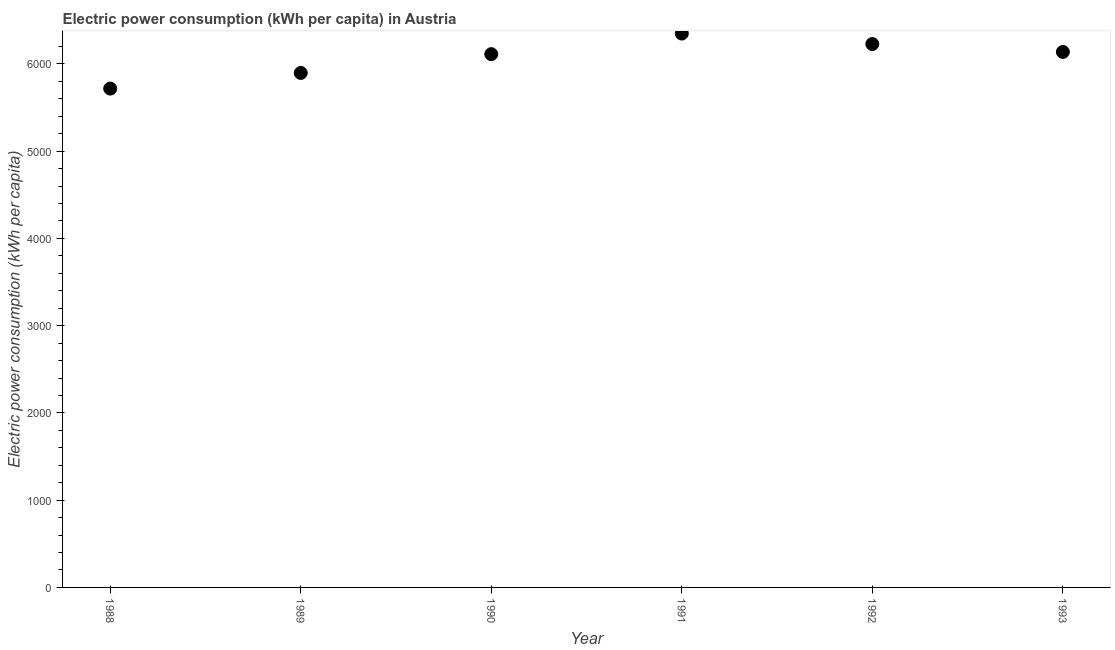What is the electric power consumption in 1993?
Make the answer very short. 6137.27. Across all years, what is the maximum electric power consumption?
Give a very brief answer. 6347.22. Across all years, what is the minimum electric power consumption?
Your answer should be compact. 5716.83. In which year was the electric power consumption maximum?
Ensure brevity in your answer.  1991. What is the sum of the electric power consumption?
Offer a terse response. 3.64e+04. What is the difference between the electric power consumption in 1988 and 1989?
Provide a short and direct response. -179.3. What is the average electric power consumption per year?
Your answer should be compact. 6072.74. What is the median electric power consumption?
Keep it short and to the point. 6124.37. In how many years, is the electric power consumption greater than 2000 kWh per capita?
Your answer should be very brief. 6. What is the ratio of the electric power consumption in 1991 to that in 1992?
Offer a very short reply. 1.02. Is the difference between the electric power consumption in 1990 and 1993 greater than the difference between any two years?
Offer a very short reply. No. What is the difference between the highest and the second highest electric power consumption?
Provide a succinct answer. 119.72. Is the sum of the electric power consumption in 1988 and 1992 greater than the maximum electric power consumption across all years?
Your answer should be compact. Yes. What is the difference between the highest and the lowest electric power consumption?
Your response must be concise. 630.39. Does the electric power consumption monotonically increase over the years?
Offer a terse response. No. How many years are there in the graph?
Your answer should be compact. 6. Are the values on the major ticks of Y-axis written in scientific E-notation?
Offer a terse response. No. Does the graph contain grids?
Ensure brevity in your answer.  No. What is the title of the graph?
Your answer should be very brief. Electric power consumption (kWh per capita) in Austria. What is the label or title of the X-axis?
Provide a short and direct response. Year. What is the label or title of the Y-axis?
Provide a succinct answer. Electric power consumption (kWh per capita). What is the Electric power consumption (kWh per capita) in 1988?
Your response must be concise. 5716.83. What is the Electric power consumption (kWh per capita) in 1989?
Provide a short and direct response. 5896.14. What is the Electric power consumption (kWh per capita) in 1990?
Your answer should be compact. 6111.48. What is the Electric power consumption (kWh per capita) in 1991?
Make the answer very short. 6347.22. What is the Electric power consumption (kWh per capita) in 1992?
Keep it short and to the point. 6227.5. What is the Electric power consumption (kWh per capita) in 1993?
Make the answer very short. 6137.27. What is the difference between the Electric power consumption (kWh per capita) in 1988 and 1989?
Provide a short and direct response. -179.3. What is the difference between the Electric power consumption (kWh per capita) in 1988 and 1990?
Ensure brevity in your answer.  -394.64. What is the difference between the Electric power consumption (kWh per capita) in 1988 and 1991?
Your response must be concise. -630.39. What is the difference between the Electric power consumption (kWh per capita) in 1988 and 1992?
Keep it short and to the point. -510.66. What is the difference between the Electric power consumption (kWh per capita) in 1988 and 1993?
Ensure brevity in your answer.  -420.44. What is the difference between the Electric power consumption (kWh per capita) in 1989 and 1990?
Your response must be concise. -215.34. What is the difference between the Electric power consumption (kWh per capita) in 1989 and 1991?
Your response must be concise. -451.08. What is the difference between the Electric power consumption (kWh per capita) in 1989 and 1992?
Offer a terse response. -331.36. What is the difference between the Electric power consumption (kWh per capita) in 1989 and 1993?
Ensure brevity in your answer.  -241.13. What is the difference between the Electric power consumption (kWh per capita) in 1990 and 1991?
Give a very brief answer. -235.74. What is the difference between the Electric power consumption (kWh per capita) in 1990 and 1992?
Provide a succinct answer. -116.02. What is the difference between the Electric power consumption (kWh per capita) in 1990 and 1993?
Provide a short and direct response. -25.79. What is the difference between the Electric power consumption (kWh per capita) in 1991 and 1992?
Your answer should be very brief. 119.72. What is the difference between the Electric power consumption (kWh per capita) in 1991 and 1993?
Give a very brief answer. 209.95. What is the difference between the Electric power consumption (kWh per capita) in 1992 and 1993?
Your answer should be very brief. 90.23. What is the ratio of the Electric power consumption (kWh per capita) in 1988 to that in 1990?
Your answer should be compact. 0.94. What is the ratio of the Electric power consumption (kWh per capita) in 1988 to that in 1991?
Provide a short and direct response. 0.9. What is the ratio of the Electric power consumption (kWh per capita) in 1988 to that in 1992?
Give a very brief answer. 0.92. What is the ratio of the Electric power consumption (kWh per capita) in 1989 to that in 1991?
Make the answer very short. 0.93. What is the ratio of the Electric power consumption (kWh per capita) in 1989 to that in 1992?
Provide a succinct answer. 0.95. What is the ratio of the Electric power consumption (kWh per capita) in 1989 to that in 1993?
Ensure brevity in your answer.  0.96. What is the ratio of the Electric power consumption (kWh per capita) in 1991 to that in 1993?
Give a very brief answer. 1.03. 